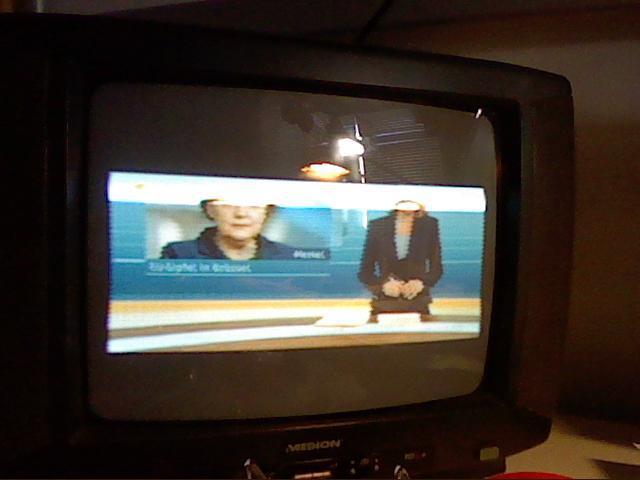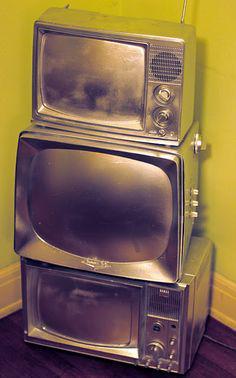The first image is the image on the left, the second image is the image on the right. For the images shown, is this caption "There are three stacks of  televisions stacked three high next to each other." true? Answer yes or no. No. The first image is the image on the left, the second image is the image on the right. Analyze the images presented: Is the assertion "There are nine identical TVs placed on each other with exactly two circle knobs on the right hand side of each of the nine televisions." valid? Answer yes or no. No. 